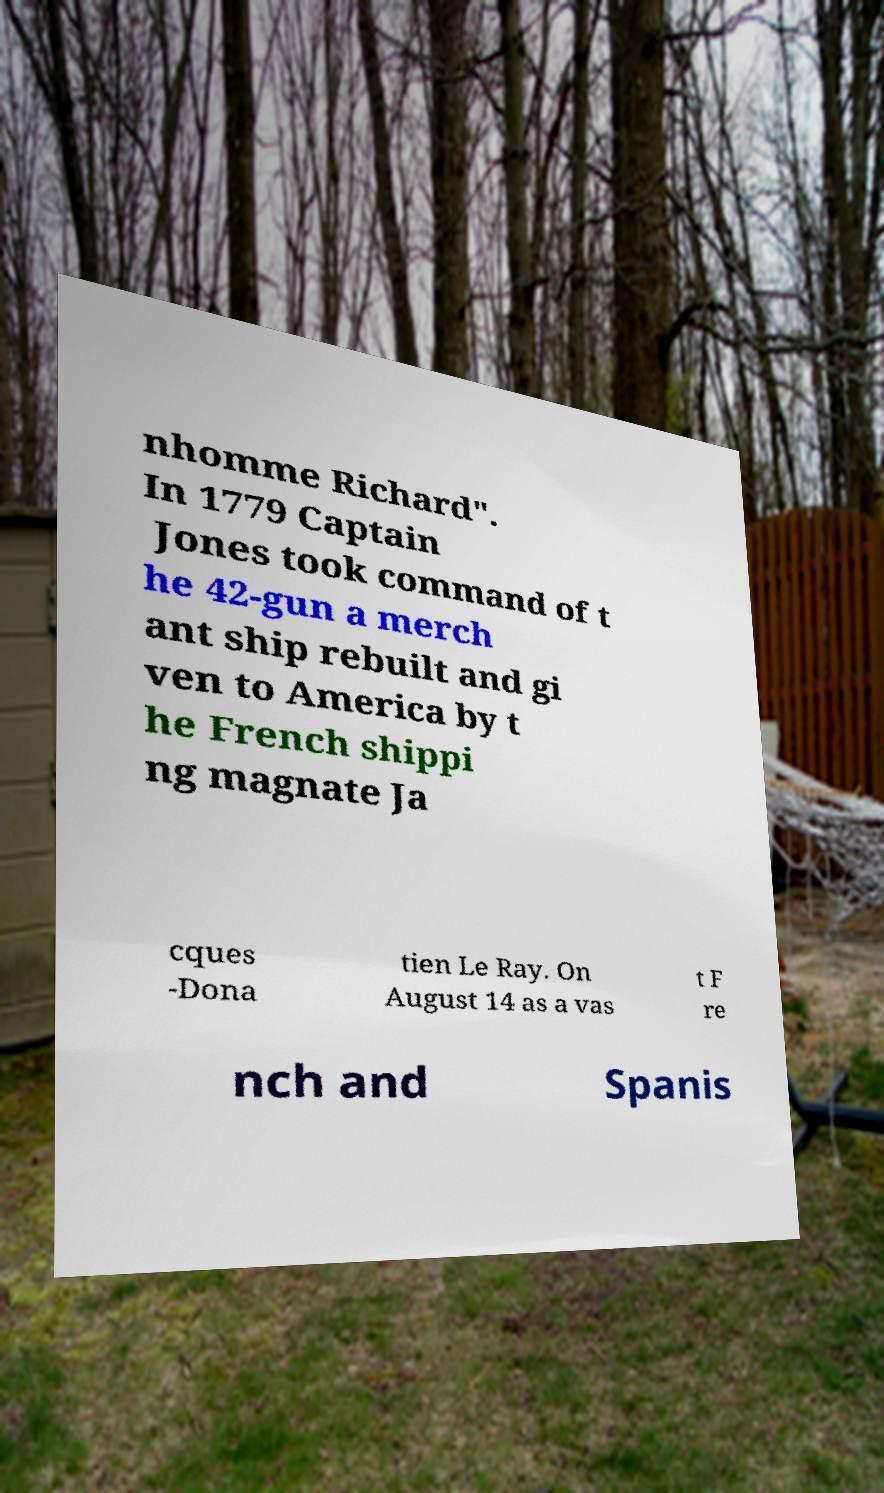What messages or text are displayed in this image? I need them in a readable, typed format. nhomme Richard". In 1779 Captain Jones took command of t he 42-gun a merch ant ship rebuilt and gi ven to America by t he French shippi ng magnate Ja cques -Dona tien Le Ray. On August 14 as a vas t F re nch and Spanis 